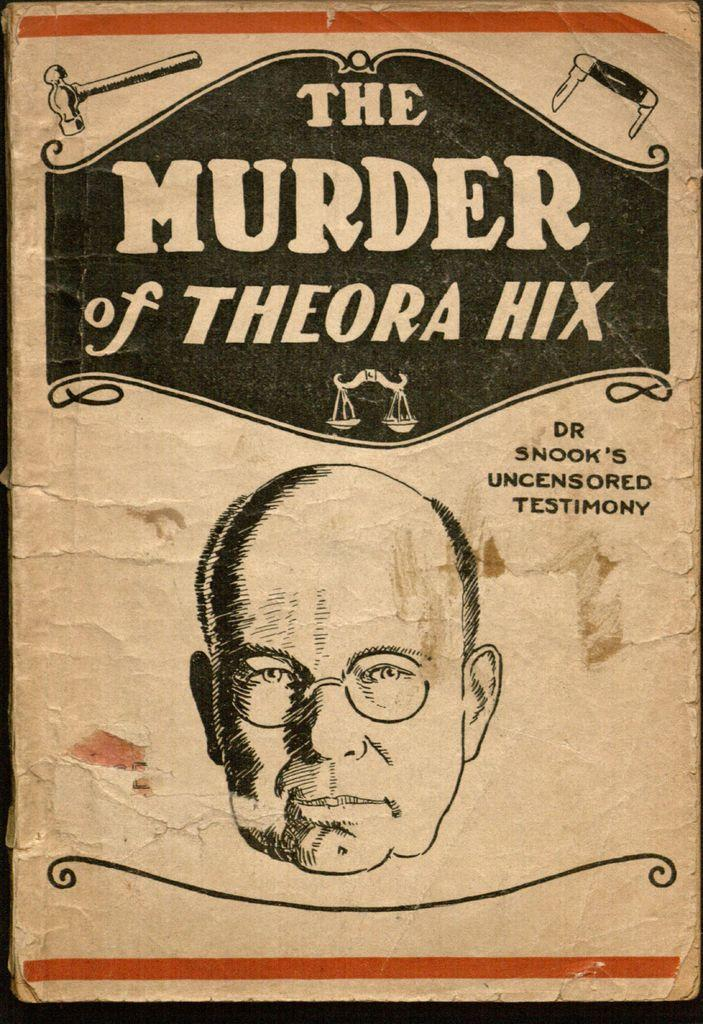What object can be seen in the image? There is a book in the image. Can you describe the book in the image? The book appears to be a hardcover book with a visible spine. What might someone be doing with the book in the image? Someone might be reading or holding the book in the image. What type of baseball is the grandfather playing in the afternoon in the image? There is no baseball, grandfather, or afternoon depicted in the image; it only features a book. 